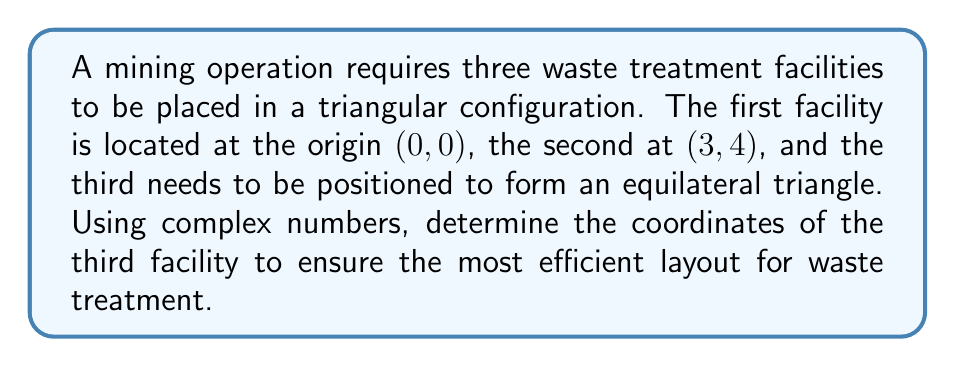Could you help me with this problem? Let's approach this step-by-step using complex numbers:

1) First, we represent the given points as complex numbers:
   $z_1 = 0 + 0i$ (origin)
   $z_2 = 3 + 4i$

2) To form an equilateral triangle, we need to rotate $z_2$ by 60° (or $\frac{\pi}{3}$ radians) around $z_1$. We can do this using the complex rotation formula:

   $z_3 = z_1 + (z_2 - z_1) \cdot e^{i\frac{\pi}{3}}$

3) Simplify:
   $z_3 = 0 + (3+4i) \cdot e^{i\frac{\pi}{3}}$

4) Recall Euler's formula: $e^{i\theta} = \cos\theta + i\sin\theta$
   $e^{i\frac{\pi}{3}} = \cos\frac{\pi}{3} + i\sin\frac{\pi}{3} = \frac{1}{2} + i\frac{\sqrt{3}}{2}$

5) Multiply:
   $z_3 = (3+4i) \cdot (\frac{1}{2} + i\frac{\sqrt{3}}{2})$
   $= (3 \cdot \frac{1}{2} - 4 \cdot \frac{\sqrt{3}}{2}) + i(3 \cdot \frac{\sqrt{3}}{2} + 4 \cdot \frac{1}{2})$
   $= (\frac{3}{2} - 2\sqrt{3}) + i(\frac{3\sqrt{3}}{2} + 2)$

6) Simplify:
   $z_3 = (\frac{3}{2} - 2\sqrt{3}) + i(\frac{3\sqrt{3}}{2} + 2)$

7) The real and imaginary parts of $z_3$ give us the x and y coordinates respectively.
Answer: $(\frac{3}{2} - 2\sqrt{3}, \frac{3\sqrt{3}}{2} + 2)$ 